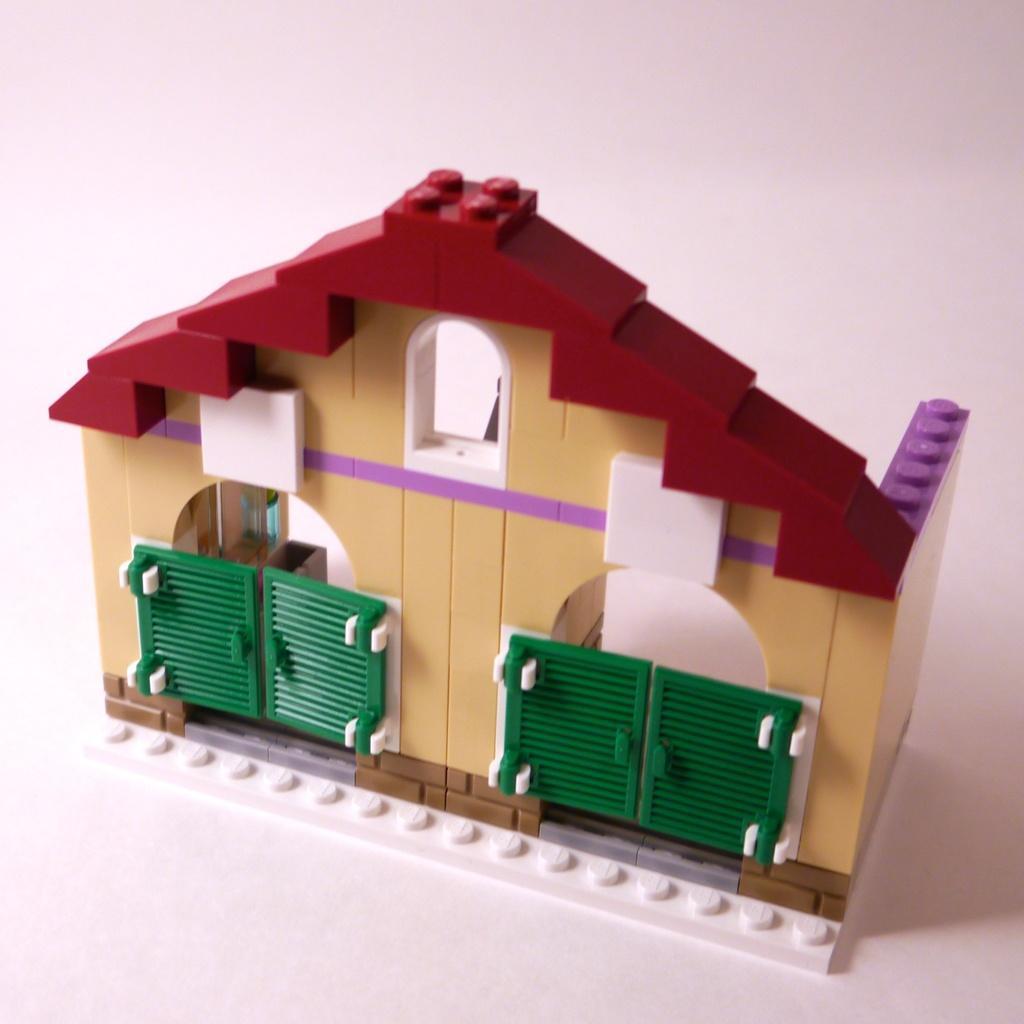How would you summarize this image in a sentence or two? In this picture we can see a toy house made of building blocks with gates. 